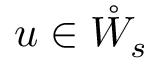<formula> <loc_0><loc_0><loc_500><loc_500>u \in \mathring { W } _ { s }</formula> 